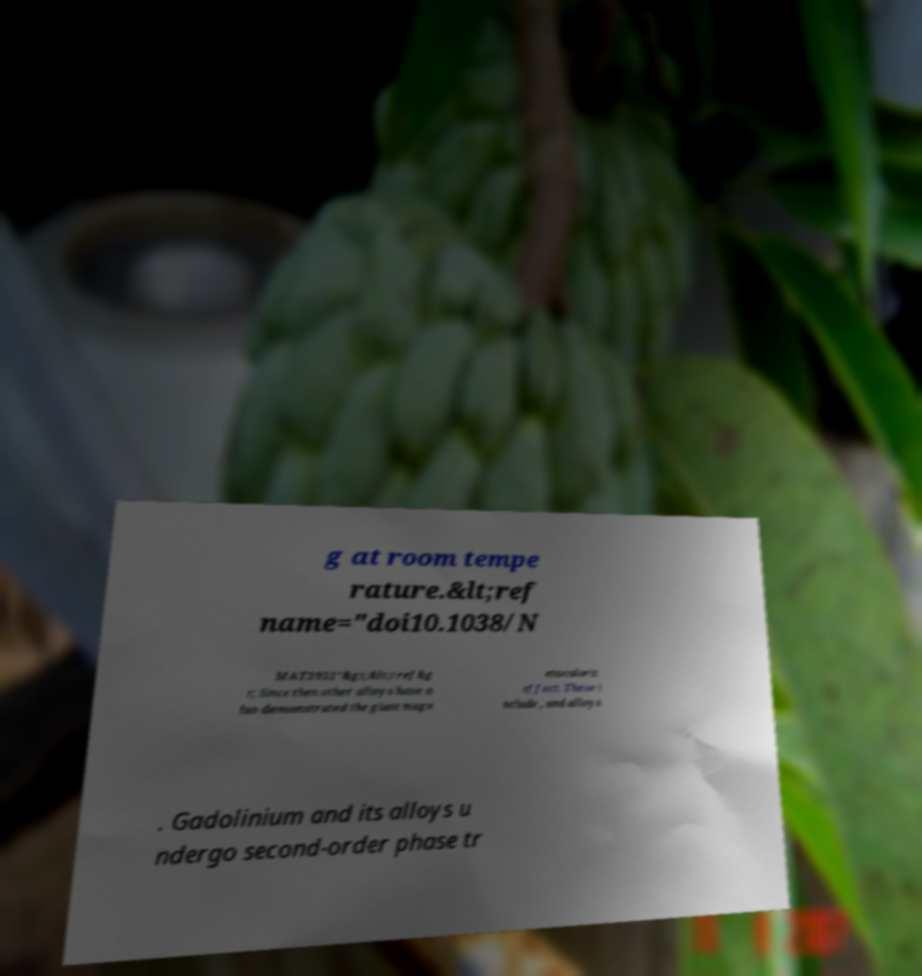Can you read and provide the text displayed in the image?This photo seems to have some interesting text. Can you extract and type it out for me? g at room tempe rature.&lt;ref name="doi10.1038/N MAT3951"&gt;&lt;/ref&g t; Since then other alloys have a lso demonstrated the giant magn etocaloric effect. These i nclude , and alloys . Gadolinium and its alloys u ndergo second-order phase tr 